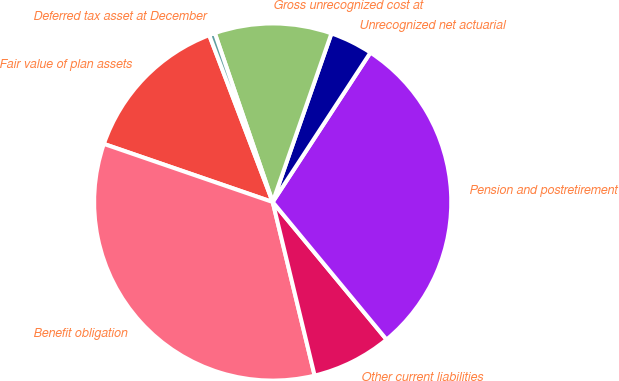<chart> <loc_0><loc_0><loc_500><loc_500><pie_chart><fcel>Fair value of plan assets<fcel>Benefit obligation<fcel>Other current liabilities<fcel>Pension and postretirement<fcel>Unrecognized net actuarial<fcel>Gross unrecognized cost at<fcel>Deferred tax asset at December<nl><fcel>13.94%<fcel>34.05%<fcel>7.23%<fcel>29.78%<fcel>3.88%<fcel>10.59%<fcel>0.53%<nl></chart> 